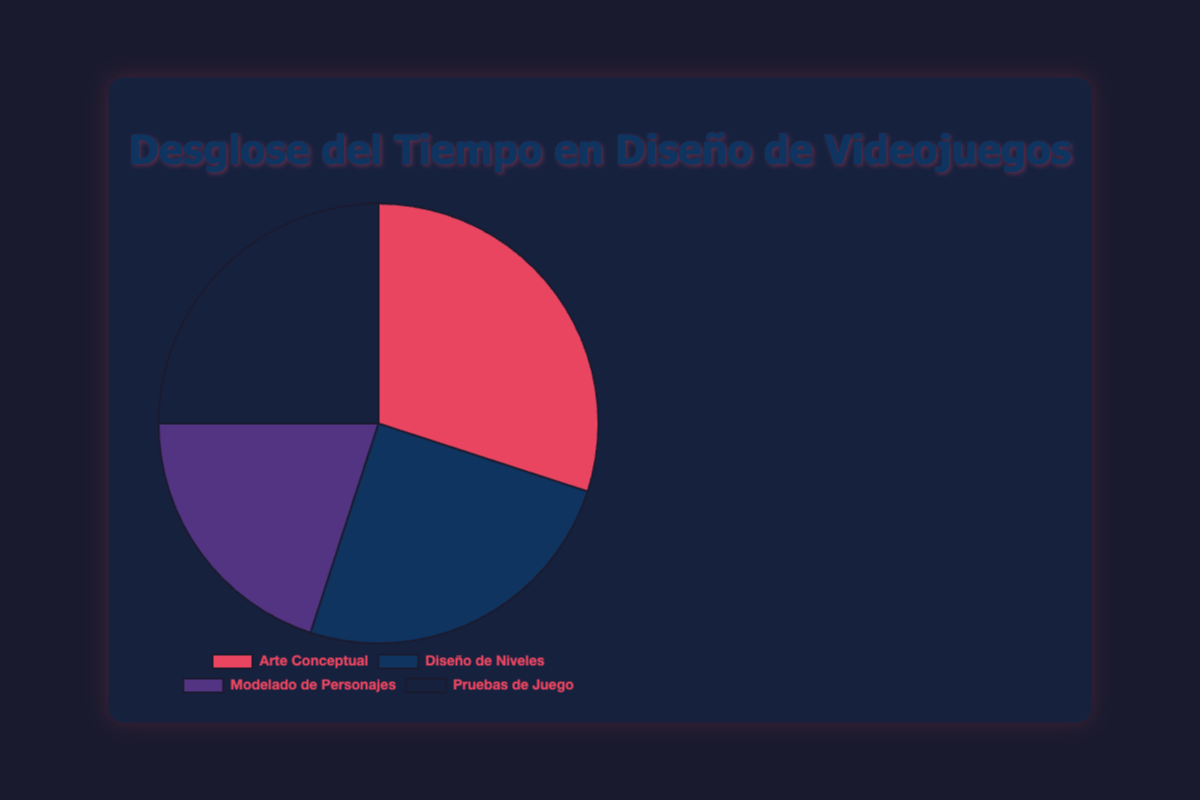What percentage of time is spent on Concept Art? The figure shows that "Concept Art" takes up a segment of the pie chart labeled with its percentage. According to the data, the "Concept Art" stage accounts for 30%.
Answer: 30% Which stages of game design take up an equal amount of time? By looking at the pie chart, we can compare the sizes and labeled percentages of each segment. We see that both "Level Design" and "Playtesting" each occupy 25% of the total time.
Answer: Level Design and Playtesting Which stage takes up the smallest portion of the game design time? By comparing all the percentages visually represented in the pie chart, "Character Modeling" has the lowest value at 20%.
Answer: Character Modeling How much more time is spent on Concept Art compared to Character Modeling? The percentage for Concept Art is 30%, and for Character Modeling is 20%. The difference is calculated as 30% - 20% = 10%.
Answer: 10% What is the combined percentage of time spent on Level Design and Playtesting? To find the combined percentage, we add the values for Level Design (25%) and Playtesting (25%). So, 25% + 25% = 50%.
Answer: 50% What is the second most time-consuming stage in the game design process? The pie chart shows that "Concept Art" takes the highest percentage at 30%, hence the next is tie between "Level Design" and "Playtesting", each taking 25%.
Answer: Level Design and Playtesting Which stage is represented by the darkest color on the pie chart? Visually observing the colors in the pie chart, the darkest color in the provided color scheme corresponds with "Playtesting".
Answer: Playtesting If additional 10% time were to be allocated equally from "Concept Art" to "Character Modeling", what would be their new percentages? Subtract 10% from Concept Art's 30% and add this 10% to Character Modeling's 20%. This results in: Concept Art = 30% - 10% = 20%, and Character Modeling = 20% + 10% = 30%.
Answer: Concept Art: 20%, Character Modeling: 30% If the total time spent on game design was 200 hours, how many hours are spent on each stage? Calculate the hours for each stage based on their percentages: 
- Concept Art: 200 * 30/100 = 60 hours
- Level Design: 200 * 25/100 = 50 hours
- Character Modeling: 200 * 20/100 = 40 hours
- Playtesting: 200 * 25/100 = 50 hours.
Answer: Concept Art: 60 hours, Level Design: 50 hours, Character Modeling: 40 hours, Playtesting: 50 hours 